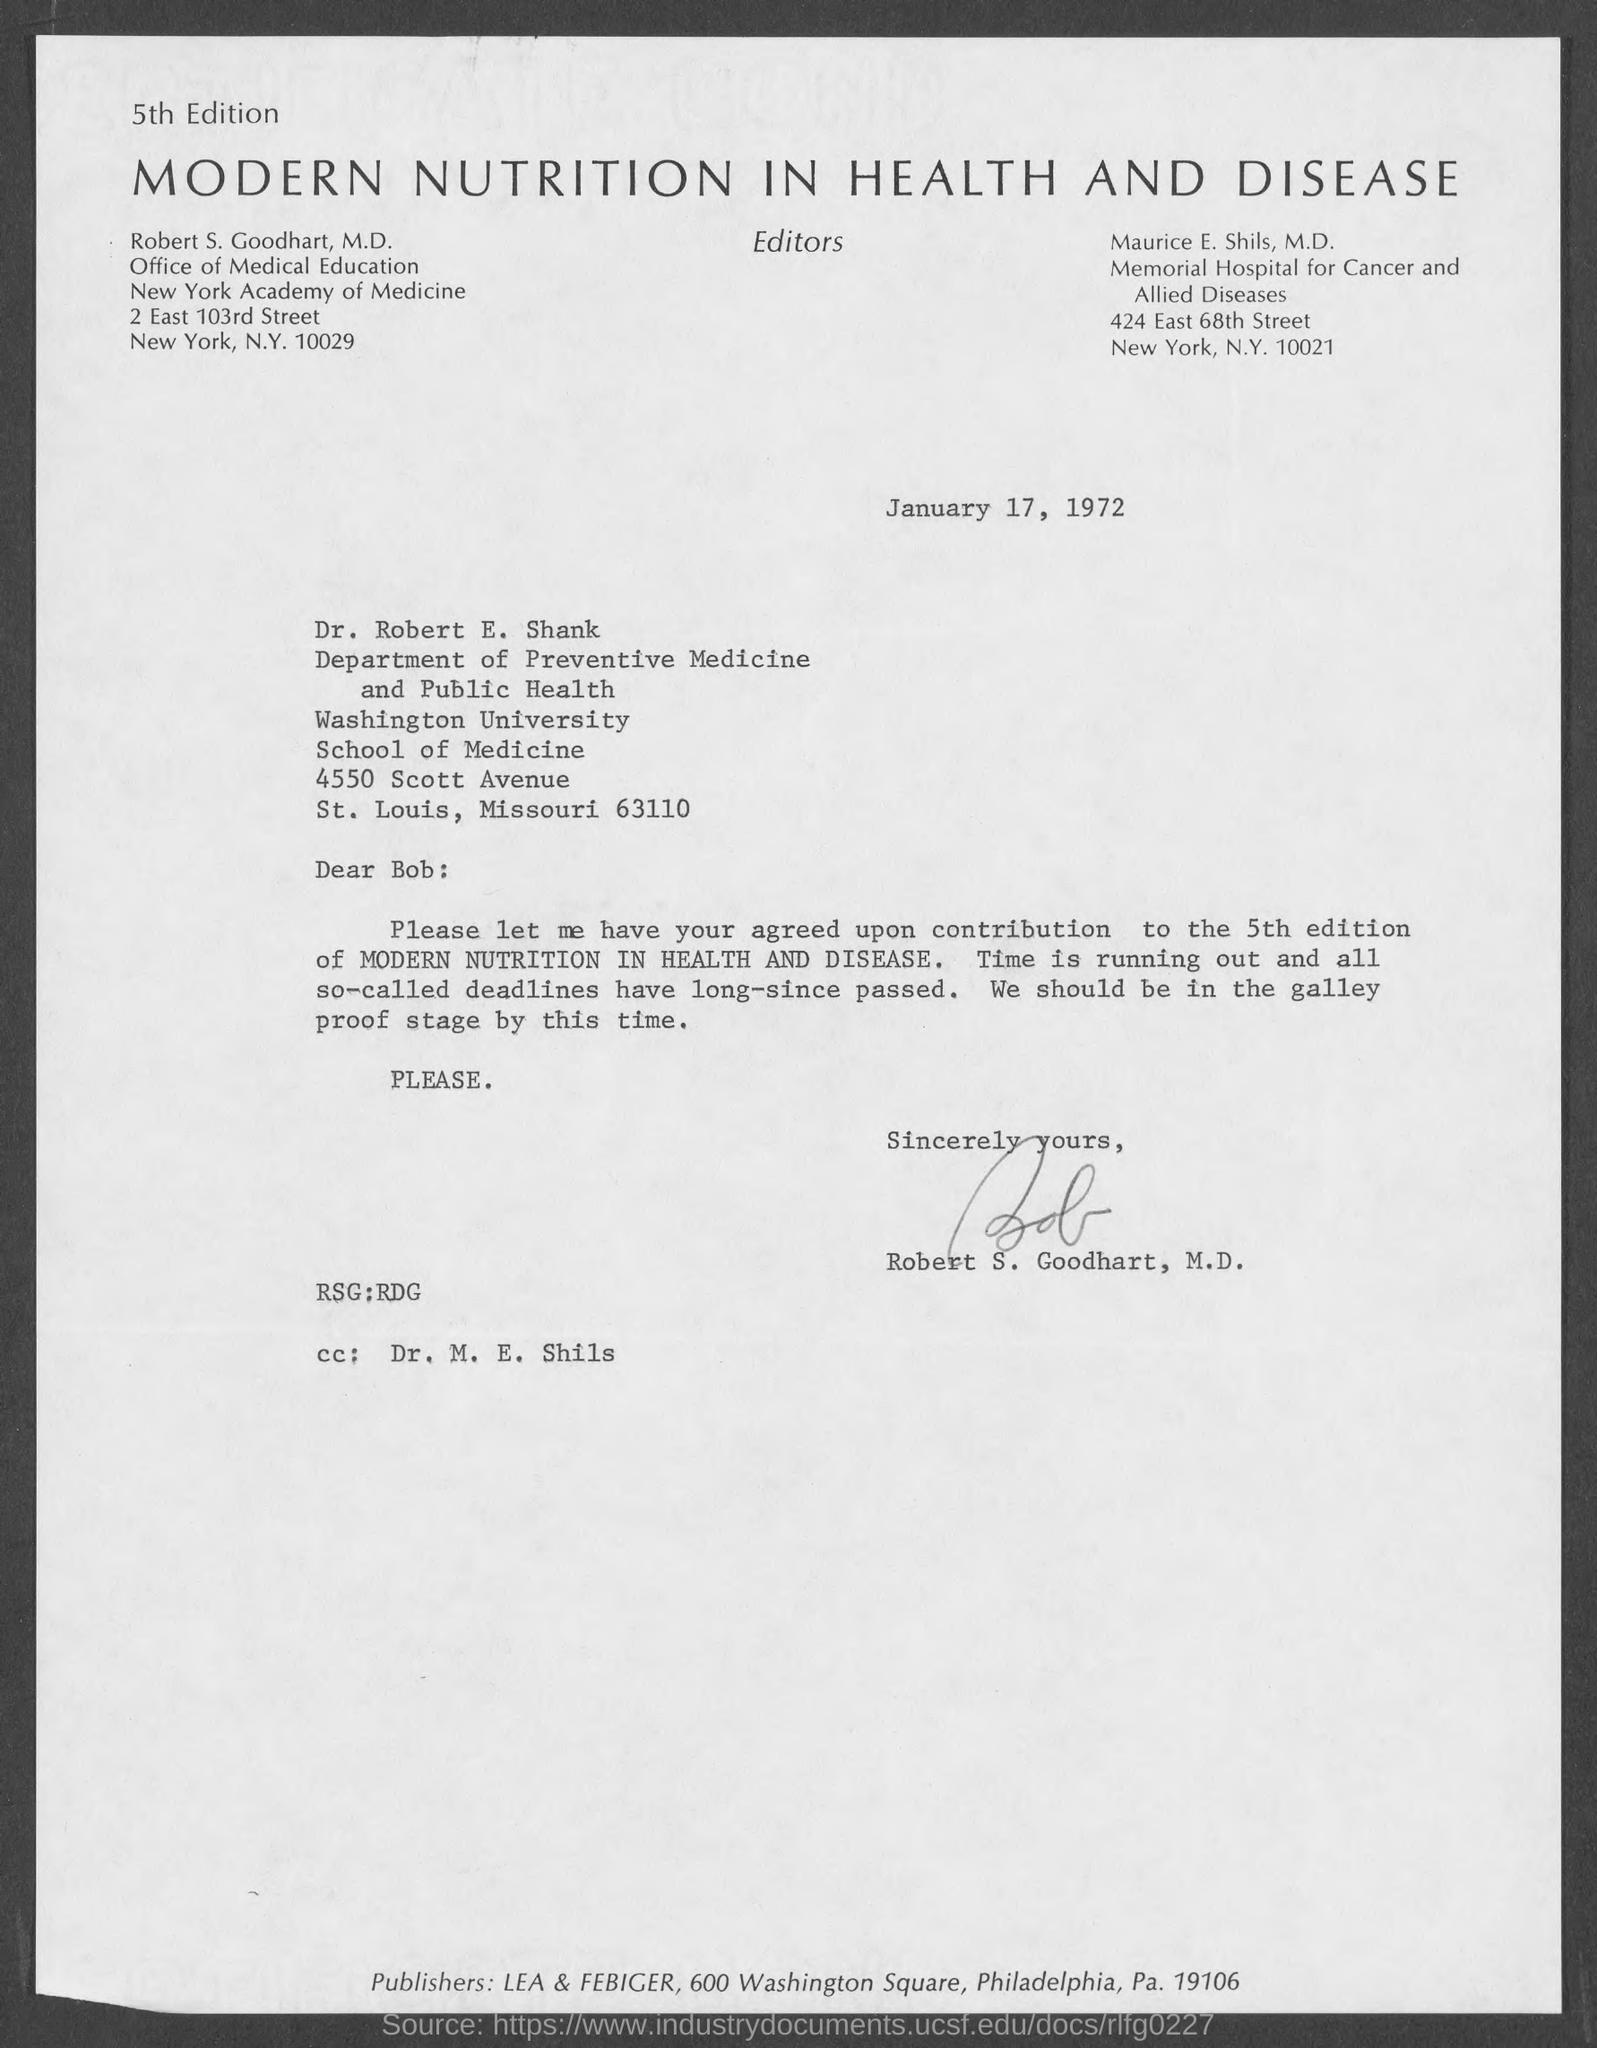Highlight a few significant elements in this photo. The letter is dated January 17, 1972. The letter was written by Robert S. Goodhart, M.D. Dr. Robert E. Shank is a member of the Department of Preventive Medicine and Public Health. 